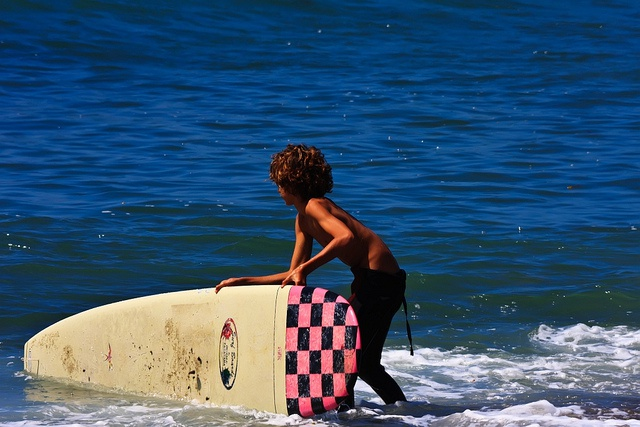Describe the objects in this image and their specific colors. I can see surfboard in darkblue, tan, and black tones and people in darkblue, black, maroon, and salmon tones in this image. 